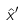Convert formula to latex. <formula><loc_0><loc_0><loc_500><loc_500>\hat { x } ^ { \prime }</formula> 